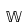<formula> <loc_0><loc_0><loc_500><loc_500>\mathbb { W }</formula> 